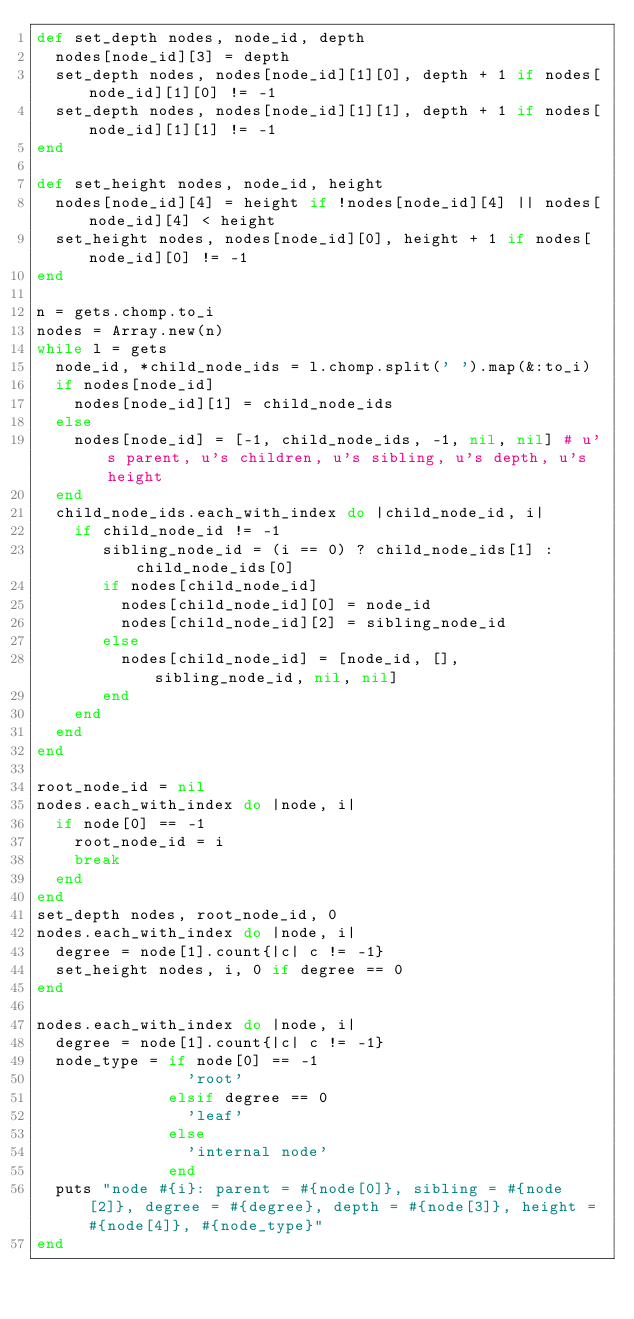Convert code to text. <code><loc_0><loc_0><loc_500><loc_500><_Ruby_>def set_depth nodes, node_id, depth
  nodes[node_id][3] = depth
  set_depth nodes, nodes[node_id][1][0], depth + 1 if nodes[node_id][1][0] != -1
  set_depth nodes, nodes[node_id][1][1], depth + 1 if nodes[node_id][1][1] != -1
end

def set_height nodes, node_id, height
  nodes[node_id][4] = height if !nodes[node_id][4] || nodes[node_id][4] < height
  set_height nodes, nodes[node_id][0], height + 1 if nodes[node_id][0] != -1
end

n = gets.chomp.to_i
nodes = Array.new(n)
while l = gets
  node_id, *child_node_ids = l.chomp.split(' ').map(&:to_i)
  if nodes[node_id]
    nodes[node_id][1] = child_node_ids
  else
    nodes[node_id] = [-1, child_node_ids, -1, nil, nil] # u's parent, u's children, u's sibling, u's depth, u's height
  end
  child_node_ids.each_with_index do |child_node_id, i|
    if child_node_id != -1
       sibling_node_id = (i == 0) ? child_node_ids[1] : child_node_ids[0]
       if nodes[child_node_id]
         nodes[child_node_id][0] = node_id
         nodes[child_node_id][2] = sibling_node_id
       else
         nodes[child_node_id] = [node_id, [], sibling_node_id, nil, nil]
       end
    end
  end
end

root_node_id = nil
nodes.each_with_index do |node, i|
  if node[0] == -1
    root_node_id = i
    break
  end
end
set_depth nodes, root_node_id, 0
nodes.each_with_index do |node, i|
  degree = node[1].count{|c| c != -1}
  set_height nodes, i, 0 if degree == 0
end

nodes.each_with_index do |node, i|
  degree = node[1].count{|c| c != -1}
  node_type = if node[0] == -1
                'root'
              elsif degree == 0
                'leaf'
              else
                'internal node'
              end
  puts "node #{i}: parent = #{node[0]}, sibling = #{node[2]}, degree = #{degree}, depth = #{node[3]}, height = #{node[4]}, #{node_type}"
end
</code> 